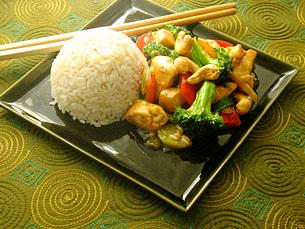What utensil will the food be eaten with? chopsticks 